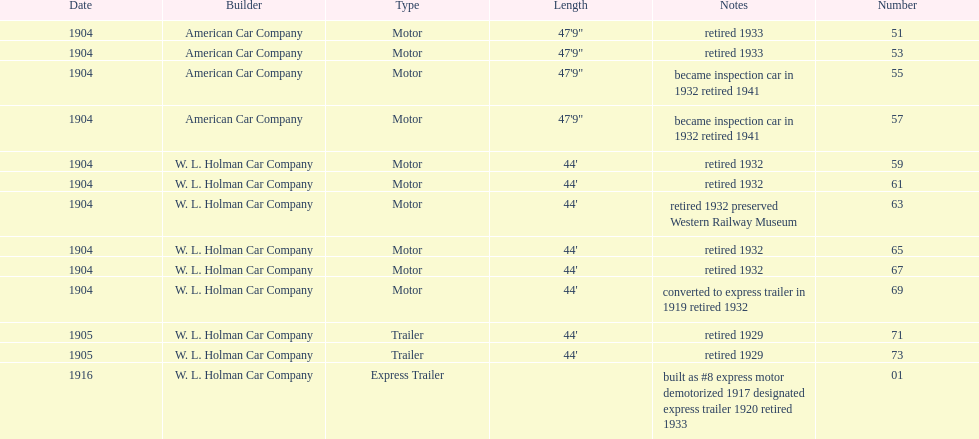How long did it take number 71 to retire? 24. 